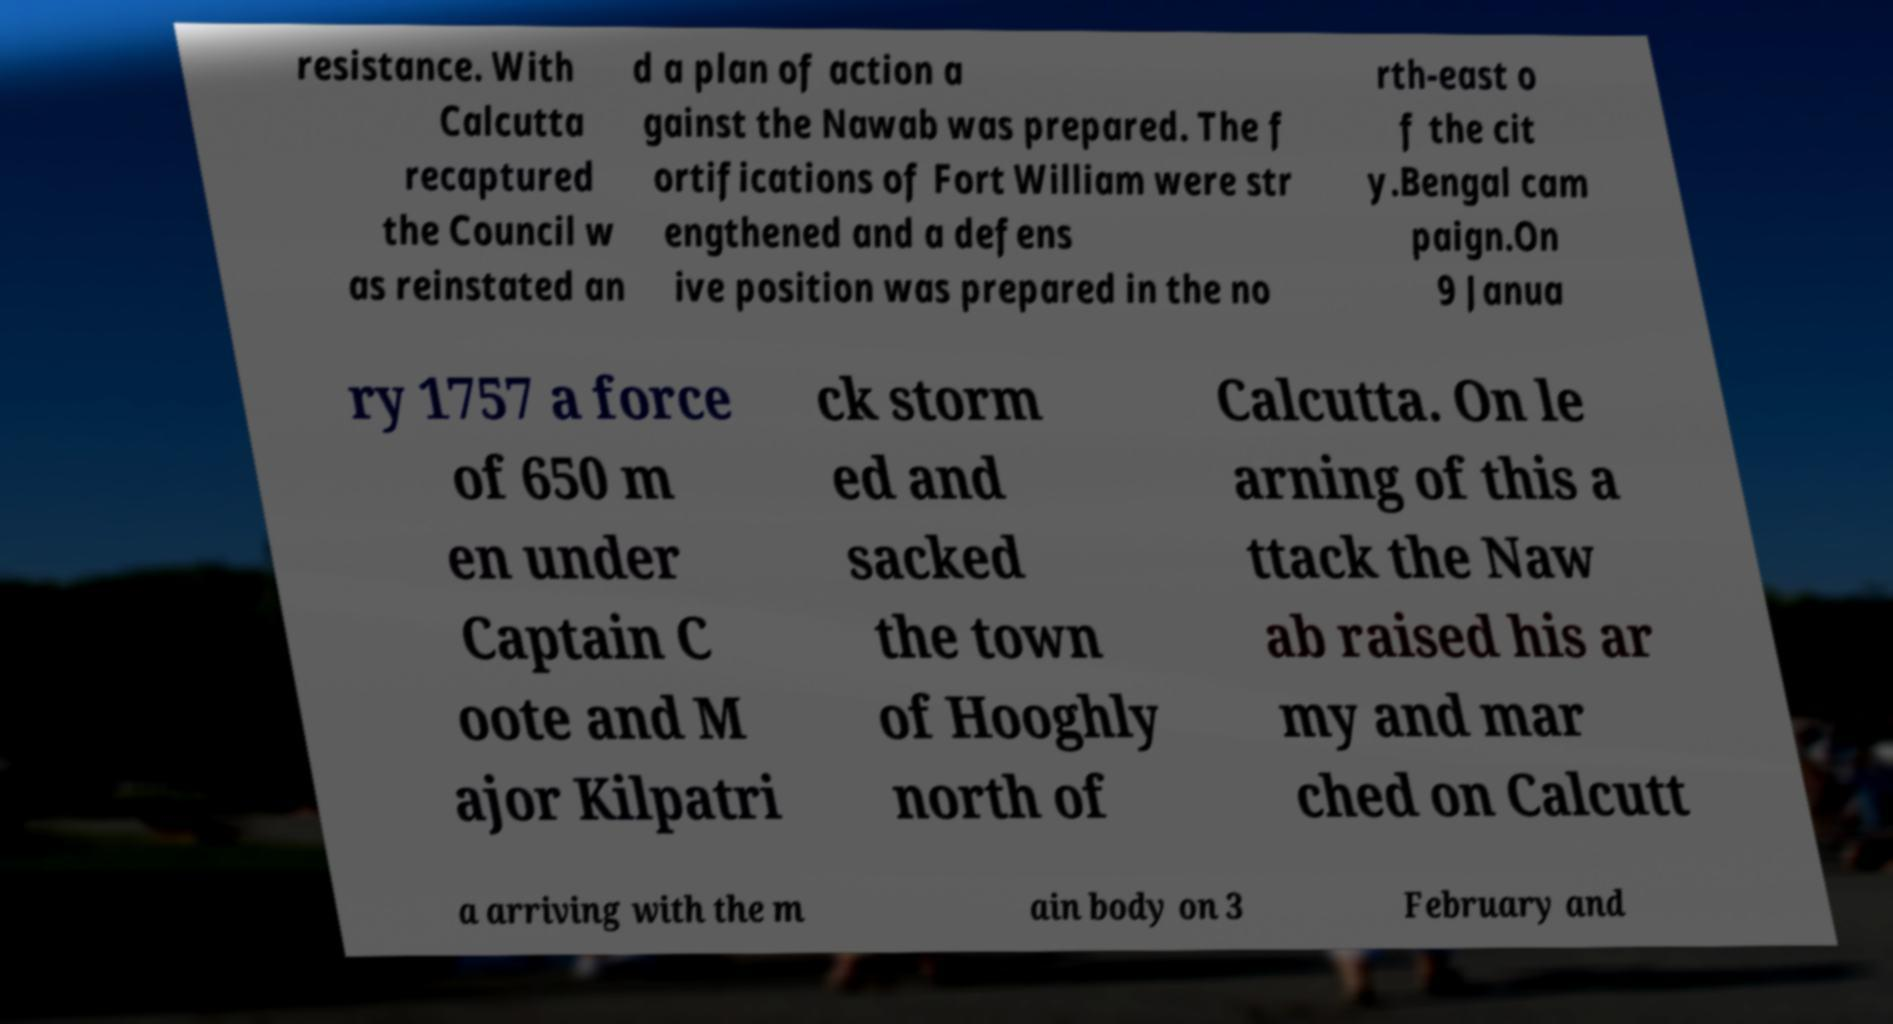There's text embedded in this image that I need extracted. Can you transcribe it verbatim? resistance. With Calcutta recaptured the Council w as reinstated an d a plan of action a gainst the Nawab was prepared. The f ortifications of Fort William were str engthened and a defens ive position was prepared in the no rth-east o f the cit y.Bengal cam paign.On 9 Janua ry 1757 a force of 650 m en under Captain C oote and M ajor Kilpatri ck storm ed and sacked the town of Hooghly north of Calcutta. On le arning of this a ttack the Naw ab raised his ar my and mar ched on Calcutt a arriving with the m ain body on 3 February and 